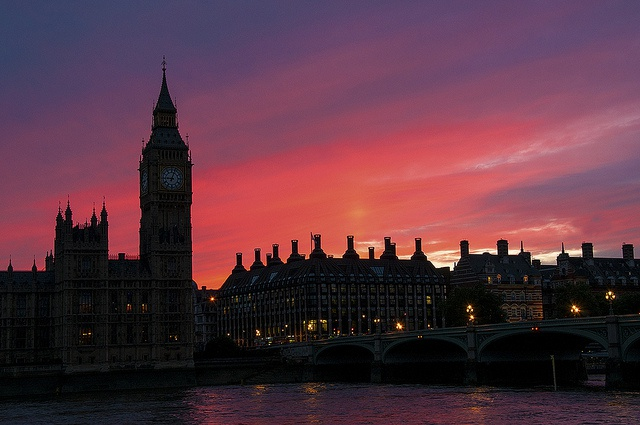Describe the objects in this image and their specific colors. I can see clock in black, navy, and darkblue tones and clock in black, darkblue, and navy tones in this image. 